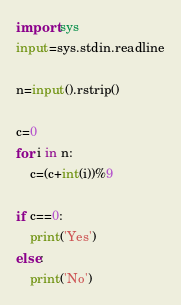Convert code to text. <code><loc_0><loc_0><loc_500><loc_500><_Python_>import sys
input=sys.stdin.readline

n=input().rstrip()

c=0
for i in n:
    c=(c+int(i))%9

if c==0:
    print('Yes')
else:
    print('No')</code> 